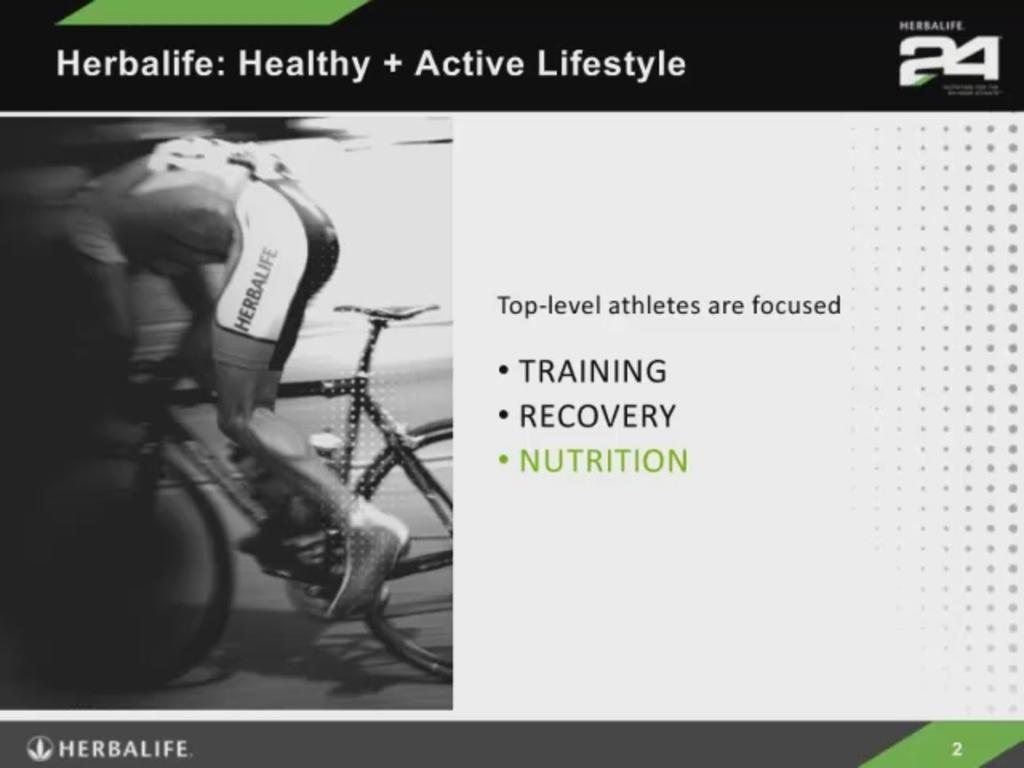What is the main subject of the image? There is a person riding a bicycle in the image. Where is the person riding the bicycle? The person is on the road. What else can be seen in the background of the image? There is text visible in the background of the image. What type of gun is the person holding while riding the bicycle? There is no gun present in the image; the person is riding a bicycle and there is no indication of any weapon. 